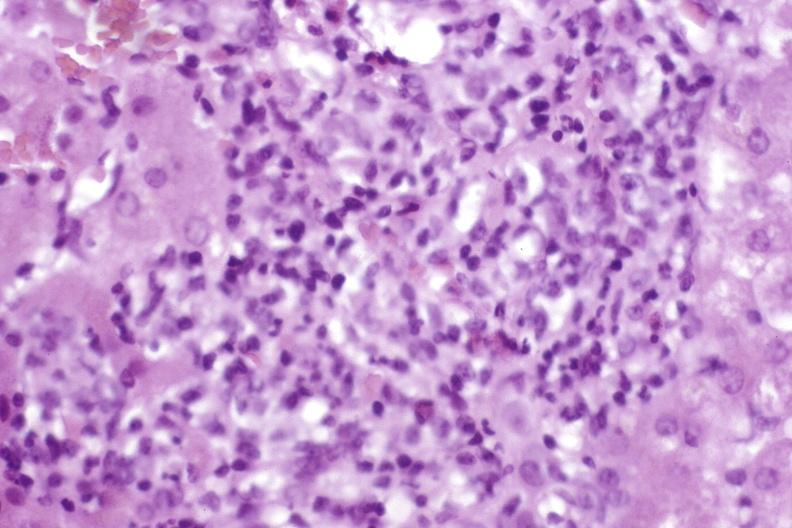s chordoma present?
Answer the question using a single word or phrase. No 